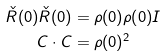Convert formula to latex. <formula><loc_0><loc_0><loc_500><loc_500>\check { R } ( 0 ) \check { R } ( 0 ) & = \rho ( 0 ) \rho ( 0 ) I \\ C \cdot C & = \rho ( 0 ) ^ { 2 }</formula> 